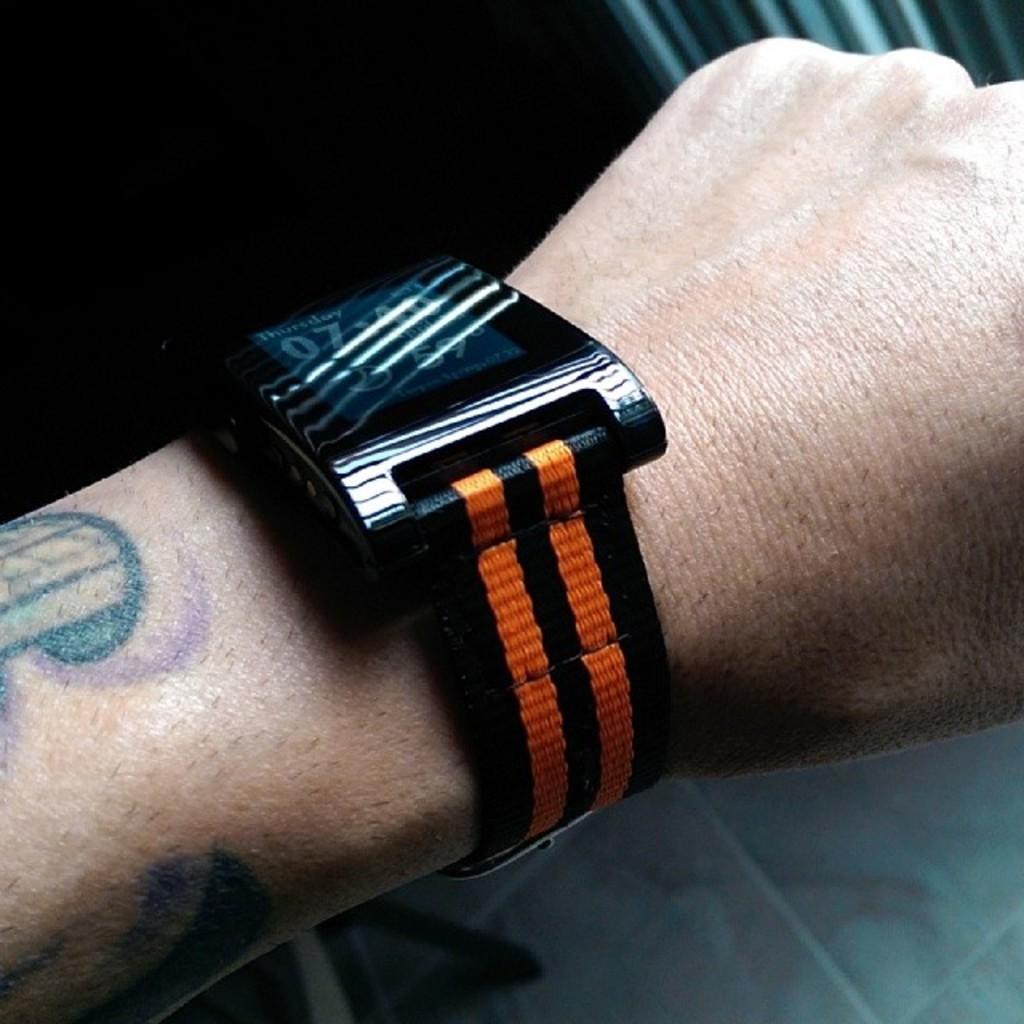Describe this image in one or two sentences. As we can see in the image there is a person wearing watch. 